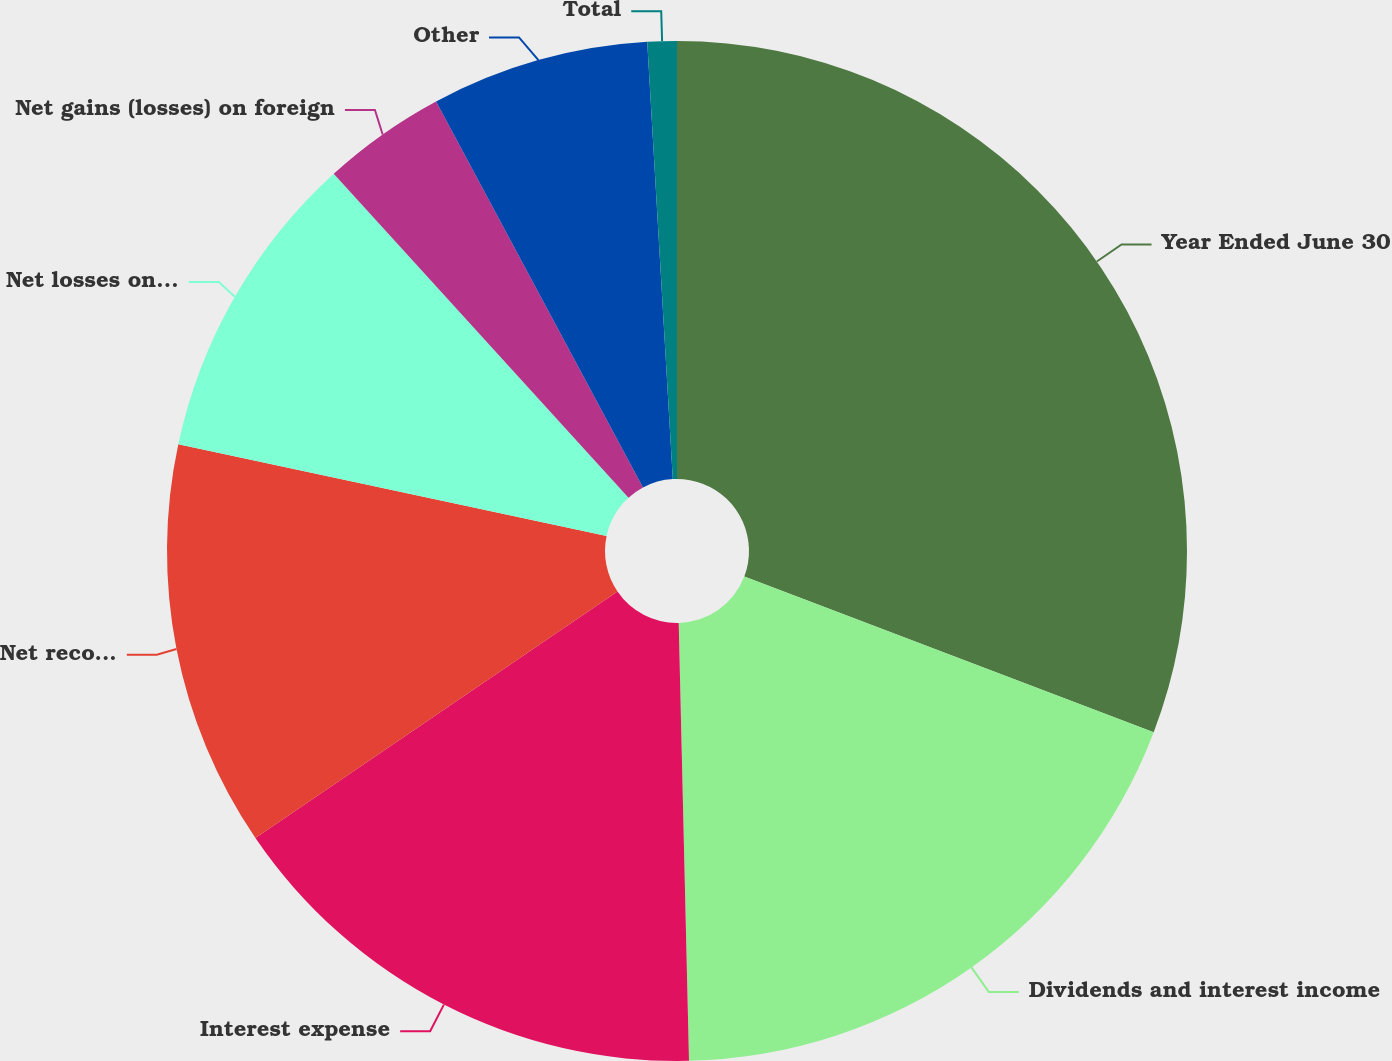Convert chart to OTSL. <chart><loc_0><loc_0><loc_500><loc_500><pie_chart><fcel>Year Ended June 30<fcel>Dividends and interest income<fcel>Interest expense<fcel>Net recognized gains on<fcel>Net losses on derivatives<fcel>Net gains (losses) on foreign<fcel>Other<fcel>Total<nl><fcel>30.78%<fcel>18.84%<fcel>15.86%<fcel>12.87%<fcel>9.89%<fcel>3.92%<fcel>6.9%<fcel>0.93%<nl></chart> 